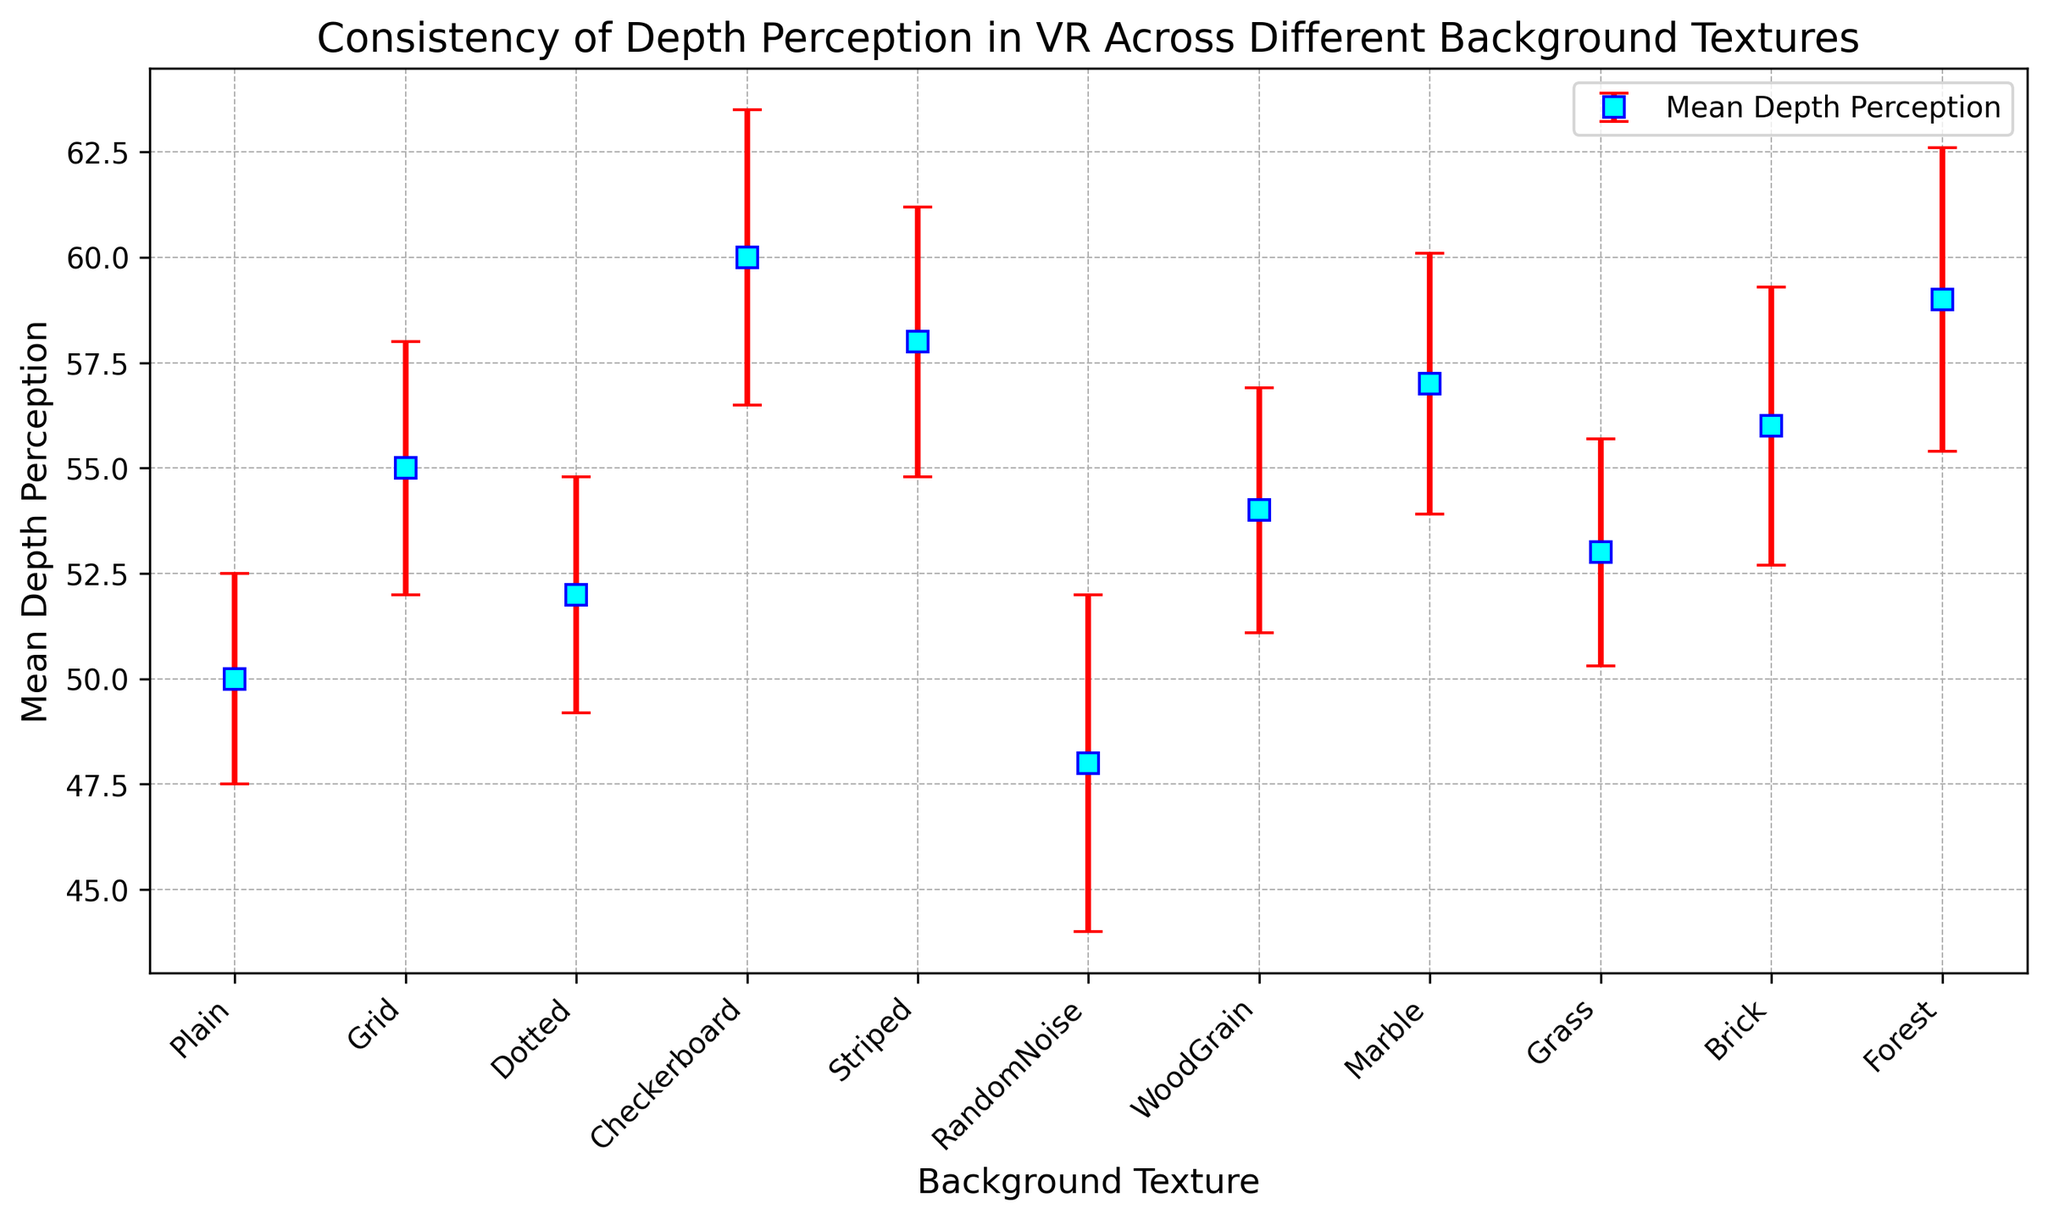What background texture has the highest mean depth perception? Examine the data points or plot markers on the figure. Identify the one with the highest y-value, which corresponds to the mean depth perception. Checkerboard has the highest point.
Answer: Checkerboard Which background texture has the lowest mean depth perception? Examine the plot for the marker with the lowest y-value, which indicates the mean depth perception. RandomNoise has the lowest point.
Answer: RandomNoise What is the average mean depth perception across all background textures? Add up all the mean depth perceptions and divide by the number of textures. (50 + 55 + 52 + 60 + 58 + 48 + 54 + 57 + 53 + 56 + 59) / 11 = 54.
Answer: 54 Which textures have a mean depth perception greater than 55? Identify all the textures with a y-value (mean depth perception) greater than 55. Checkerboard, Striped, Marble, Forest
Answer: Checkerboard, Striped, Marble, Forest What is the range of standard deviations for the mean depth perceptions? Identify the smallest and largest standard deviation values and calculate the range. The smallest standard deviation is 2.5 (Plain), and the largest is 4.0 (RandomNoise). The range is 4.0 - 2.5 = 1.5.
Answer: 1.5 Compare the mean depth perceptions of the Dotted and Grid textures. Which one is higher, and by how much? Find the mean depth perceptions of Dotted (52) and Grid (55). Subtract the smaller from the larger value. 55 - 52 = 3. Grid is higher by 3.
Answer: Grid, by 3 Which textures have the same standard deviation? Identify textures with the same y-error size (standard deviation). No two textures have the same standard deviation in this dataset.
Answer: None What is the median mean depth perception? Arrange the mean depth perceptions in numeric order and find the middle value. The sorted list is [48, 50, 52, 53, 54, 55, 56, 57, 58, 59, 60], and the median (middle value) is 55.
Answer: 55 Which texture has the largest error bar, and what is its value? Identify the texture with the longest error bar representing the standard deviation. RandomNoise has the largest error bar with a standard deviation of 4.0.
Answer: RandomNoise, 4.0 How many textures have a mean depth perception within one standard deviation of the overall mean (54)? Calculate the range of one standard deviation above and below the mean (54 - 3.16 to 54 + 3.16), approximately 50.84 to 57.16. Count the textures within this range. Plain, Dotted, WoodGrain, Marble, Grass, Brick are within this range (6 textures).
Answer: 6 